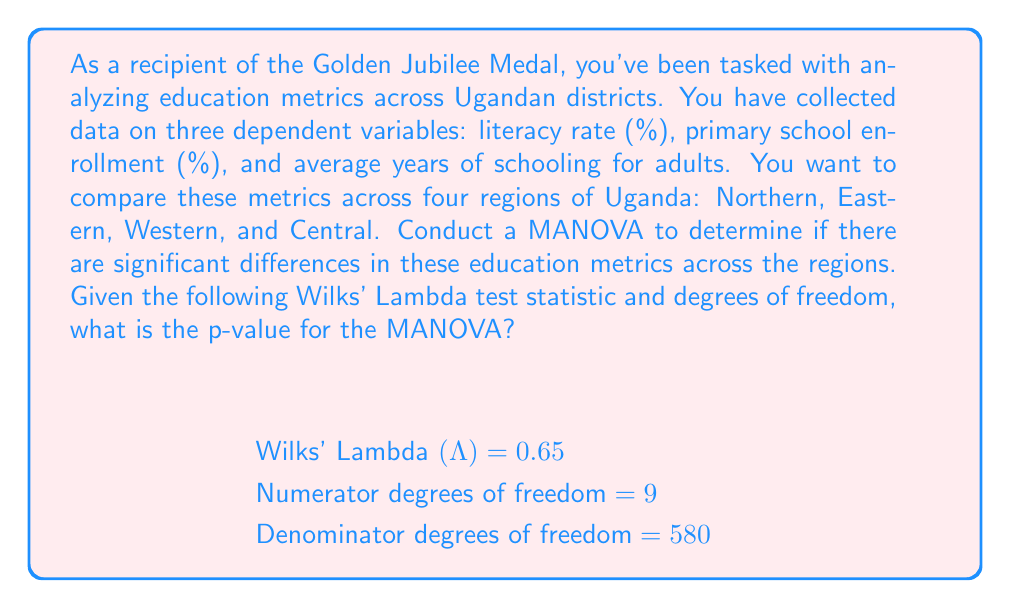Teach me how to tackle this problem. To conduct a MANOVA and interpret its results, we need to follow these steps:

1) First, we need to understand what Wilks' Lambda represents. Wilks' Lambda (Λ) is a test statistic used in MANOVA to test whether there are differences between the means of identified groups on a combination of dependent variables.

2) The null hypothesis for MANOVA is that the mean vectors of the dependent variables are equal across groups. In this case, we're testing if the mean vectors of literacy rate, primary school enrollment, and average years of schooling are equal across the four regions of Uganda.

3) To calculate the p-value, we need to transform Wilks' Lambda into an F-statistic. The formula for this transformation is:

   $$F = \frac{1-\Lambda^{1/t}}{\Lambda^{1/t}} \cdot \frac{df_2}{df_1}$$

   Where:
   $t = \sqrt{\frac{(p^2m^2-4)/(p^2+m^2-5)}{p^2+m^2-2}}$ if $p^2m^2 > 5$
   
   $p$ is the number of dependent variables
   $m$ is the number of groups minus 1
   $df_1$ is the numerator degrees of freedom
   $df_2$ is the denominator degrees of freedom

4) In our case:
   $p = 3$ (literacy rate, primary school enrollment, and average years of schooling)
   $m = 3$ (4 regions minus 1)
   $df_1 = 9$
   $df_2 = 580$

5) Calculate $t$:
   $$t = \sqrt{\frac{(3^2 \cdot 3^2-4)/(3^2+3^2-5)}{3^2+3^2-2}} = 1.732$$

6) Now we can calculate the F-statistic:
   $$F = \frac{1-0.65^{1/1.732}}{0.65^{1/1.732}} \cdot \frac{580}{9} = 28.76$$

7) With this F-statistic, we can now calculate the p-value using the F-distribution with 9 and 580 degrees of freedom.

8) Using a statistical software or F-distribution table, we find that the p-value for F(9, 580) = 28.76 is extremely small, p < 0.0001.
Answer: p < 0.0001 